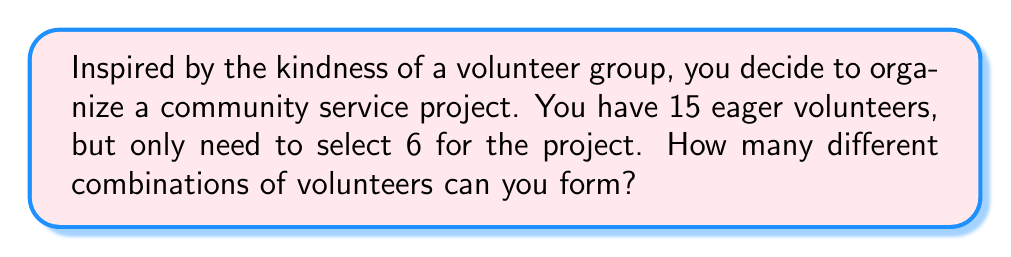Teach me how to tackle this problem. Let's approach this step-by-step:

1) This is a combination problem because the order of selection doesn't matter (it's not important who is chosen first, second, etc.).

2) We're selecting 6 people from a group of 15.

3) The formula for combinations is:

   $$C(n,r) = \frac{n!}{r!(n-r)!}$$

   Where $n$ is the total number of items to choose from, and $r$ is the number of items being chosen.

4) In this case, $n = 15$ and $r = 6$

5) Plugging these values into our formula:

   $$C(15,6) = \frac{15!}{6!(15-6)!} = \frac{15!}{6!9!}$$

6) Expanding this:

   $$\frac{15 \times 14 \times 13 \times 12 \times 11 \times 10 \times 9!}{(6 \times 5 \times 4 \times 3 \times 2 \times 1) \times 9!}$$

7) The $9!$ cancels out in the numerator and denominator:

   $$\frac{15 \times 14 \times 13 \times 12 \times 11 \times 10}{6 \times 5 \times 4 \times 3 \times 2 \times 1}$$

8) Calculating this:

   $$\frac{360360}{720} = 5005$$

Therefore, there are 5005 different combinations of volunteers that can be formed.
Answer: 5005 